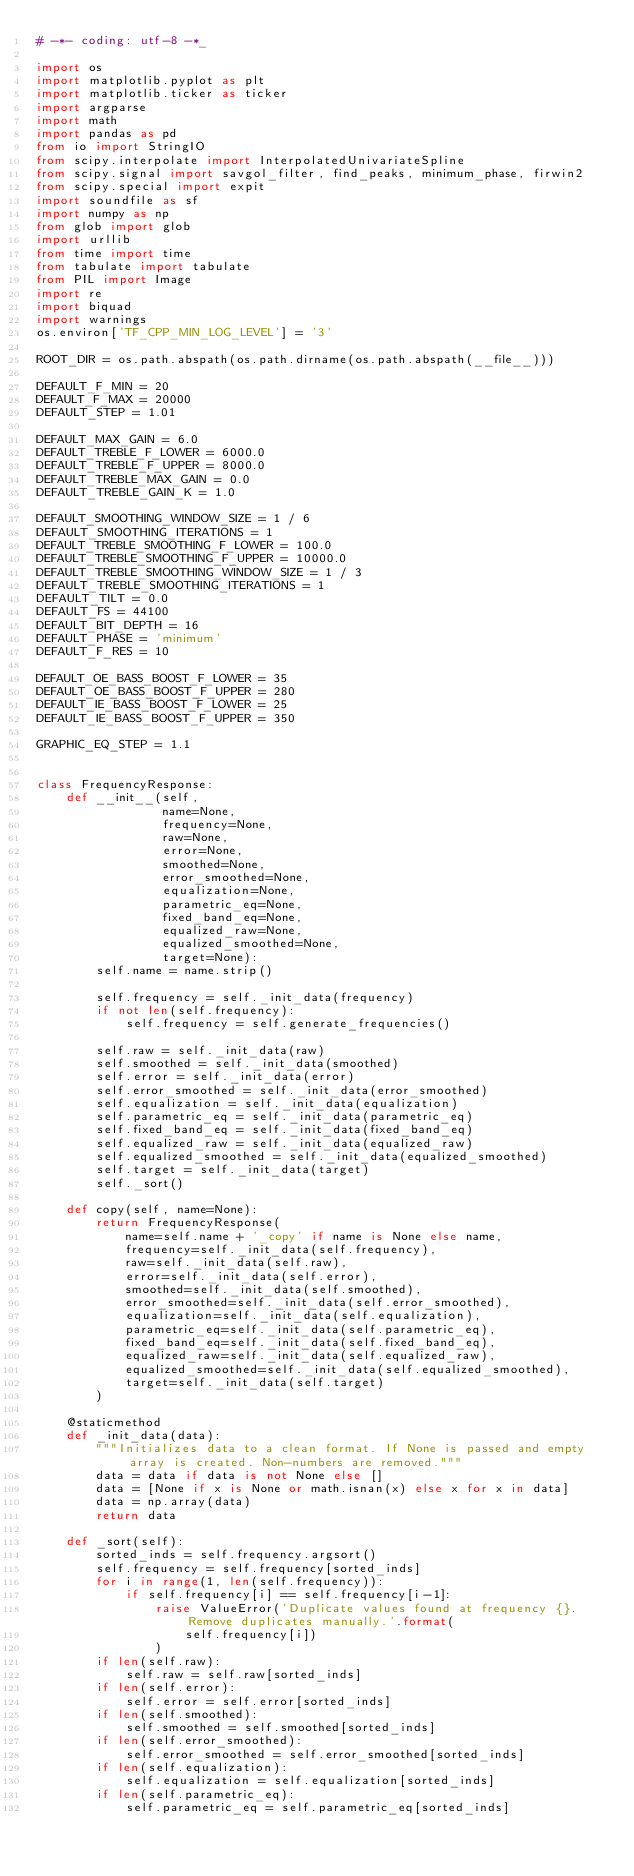<code> <loc_0><loc_0><loc_500><loc_500><_Python_># -*- coding: utf-8 -*_

import os
import matplotlib.pyplot as plt
import matplotlib.ticker as ticker
import argparse
import math
import pandas as pd
from io import StringIO
from scipy.interpolate import InterpolatedUnivariateSpline
from scipy.signal import savgol_filter, find_peaks, minimum_phase, firwin2
from scipy.special import expit
import soundfile as sf
import numpy as np
from glob import glob
import urllib
from time import time
from tabulate import tabulate
from PIL import Image
import re
import biquad
import warnings
os.environ['TF_CPP_MIN_LOG_LEVEL'] = '3'

ROOT_DIR = os.path.abspath(os.path.dirname(os.path.abspath(__file__)))

DEFAULT_F_MIN = 20
DEFAULT_F_MAX = 20000
DEFAULT_STEP = 1.01

DEFAULT_MAX_GAIN = 6.0
DEFAULT_TREBLE_F_LOWER = 6000.0
DEFAULT_TREBLE_F_UPPER = 8000.0
DEFAULT_TREBLE_MAX_GAIN = 0.0
DEFAULT_TREBLE_GAIN_K = 1.0

DEFAULT_SMOOTHING_WINDOW_SIZE = 1 / 6
DEFAULT_SMOOTHING_ITERATIONS = 1
DEFAULT_TREBLE_SMOOTHING_F_LOWER = 100.0
DEFAULT_TREBLE_SMOOTHING_F_UPPER = 10000.0
DEFAULT_TREBLE_SMOOTHING_WINDOW_SIZE = 1 / 3
DEFAULT_TREBLE_SMOOTHING_ITERATIONS = 1
DEFAULT_TILT = 0.0
DEFAULT_FS = 44100
DEFAULT_BIT_DEPTH = 16
DEFAULT_PHASE = 'minimum'
DEFAULT_F_RES = 10

DEFAULT_OE_BASS_BOOST_F_LOWER = 35
DEFAULT_OE_BASS_BOOST_F_UPPER = 280
DEFAULT_IE_BASS_BOOST_F_LOWER = 25
DEFAULT_IE_BASS_BOOST_F_UPPER = 350

GRAPHIC_EQ_STEP = 1.1


class FrequencyResponse:
    def __init__(self,
                 name=None,
                 frequency=None,
                 raw=None,
                 error=None,
                 smoothed=None,
                 error_smoothed=None,
                 equalization=None,
                 parametric_eq=None,
                 fixed_band_eq=None,
                 equalized_raw=None,
                 equalized_smoothed=None,
                 target=None):
        self.name = name.strip()

        self.frequency = self._init_data(frequency)
        if not len(self.frequency):
            self.frequency = self.generate_frequencies()

        self.raw = self._init_data(raw)
        self.smoothed = self._init_data(smoothed)
        self.error = self._init_data(error)
        self.error_smoothed = self._init_data(error_smoothed)
        self.equalization = self._init_data(equalization)
        self.parametric_eq = self._init_data(parametric_eq)
        self.fixed_band_eq = self._init_data(fixed_band_eq)
        self.equalized_raw = self._init_data(equalized_raw)
        self.equalized_smoothed = self._init_data(equalized_smoothed)
        self.target = self._init_data(target)
        self._sort()

    def copy(self, name=None):
        return FrequencyResponse(
            name=self.name + '_copy' if name is None else name,
            frequency=self._init_data(self.frequency),
            raw=self._init_data(self.raw),
            error=self._init_data(self.error),
            smoothed=self._init_data(self.smoothed),
            error_smoothed=self._init_data(self.error_smoothed),
            equalization=self._init_data(self.equalization),
            parametric_eq=self._init_data(self.parametric_eq),
            fixed_band_eq=self._init_data(self.fixed_band_eq),
            equalized_raw=self._init_data(self.equalized_raw),
            equalized_smoothed=self._init_data(self.equalized_smoothed),
            target=self._init_data(self.target)
        )

    @staticmethod
    def _init_data(data):
        """Initializes data to a clean format. If None is passed and empty array is created. Non-numbers are removed."""
        data = data if data is not None else []
        data = [None if x is None or math.isnan(x) else x for x in data]
        data = np.array(data)
        return data

    def _sort(self):
        sorted_inds = self.frequency.argsort()
        self.frequency = self.frequency[sorted_inds]
        for i in range(1, len(self.frequency)):
            if self.frequency[i] == self.frequency[i-1]:
                raise ValueError('Duplicate values found at frequency {}. Remove duplicates manually.'.format(
                    self.frequency[i])
                )
        if len(self.raw):
            self.raw = self.raw[sorted_inds]
        if len(self.error):
            self.error = self.error[sorted_inds]
        if len(self.smoothed):
            self.smoothed = self.smoothed[sorted_inds]
        if len(self.error_smoothed):
            self.error_smoothed = self.error_smoothed[sorted_inds]
        if len(self.equalization):
            self.equalization = self.equalization[sorted_inds]
        if len(self.parametric_eq):
            self.parametric_eq = self.parametric_eq[sorted_inds]</code> 